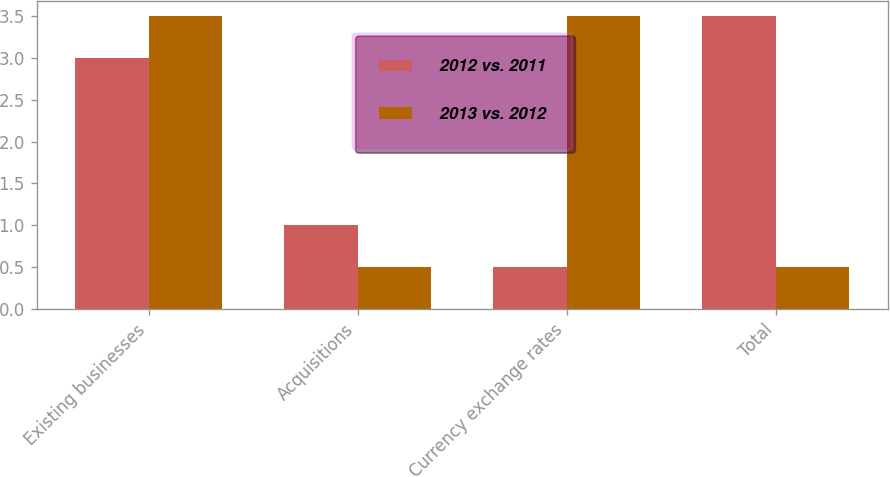Convert chart to OTSL. <chart><loc_0><loc_0><loc_500><loc_500><stacked_bar_chart><ecel><fcel>Existing businesses<fcel>Acquisitions<fcel>Currency exchange rates<fcel>Total<nl><fcel>2012 vs. 2011<fcel>3<fcel>1<fcel>0.5<fcel>3.5<nl><fcel>2013 vs. 2012<fcel>3.5<fcel>0.5<fcel>3.5<fcel>0.5<nl></chart> 